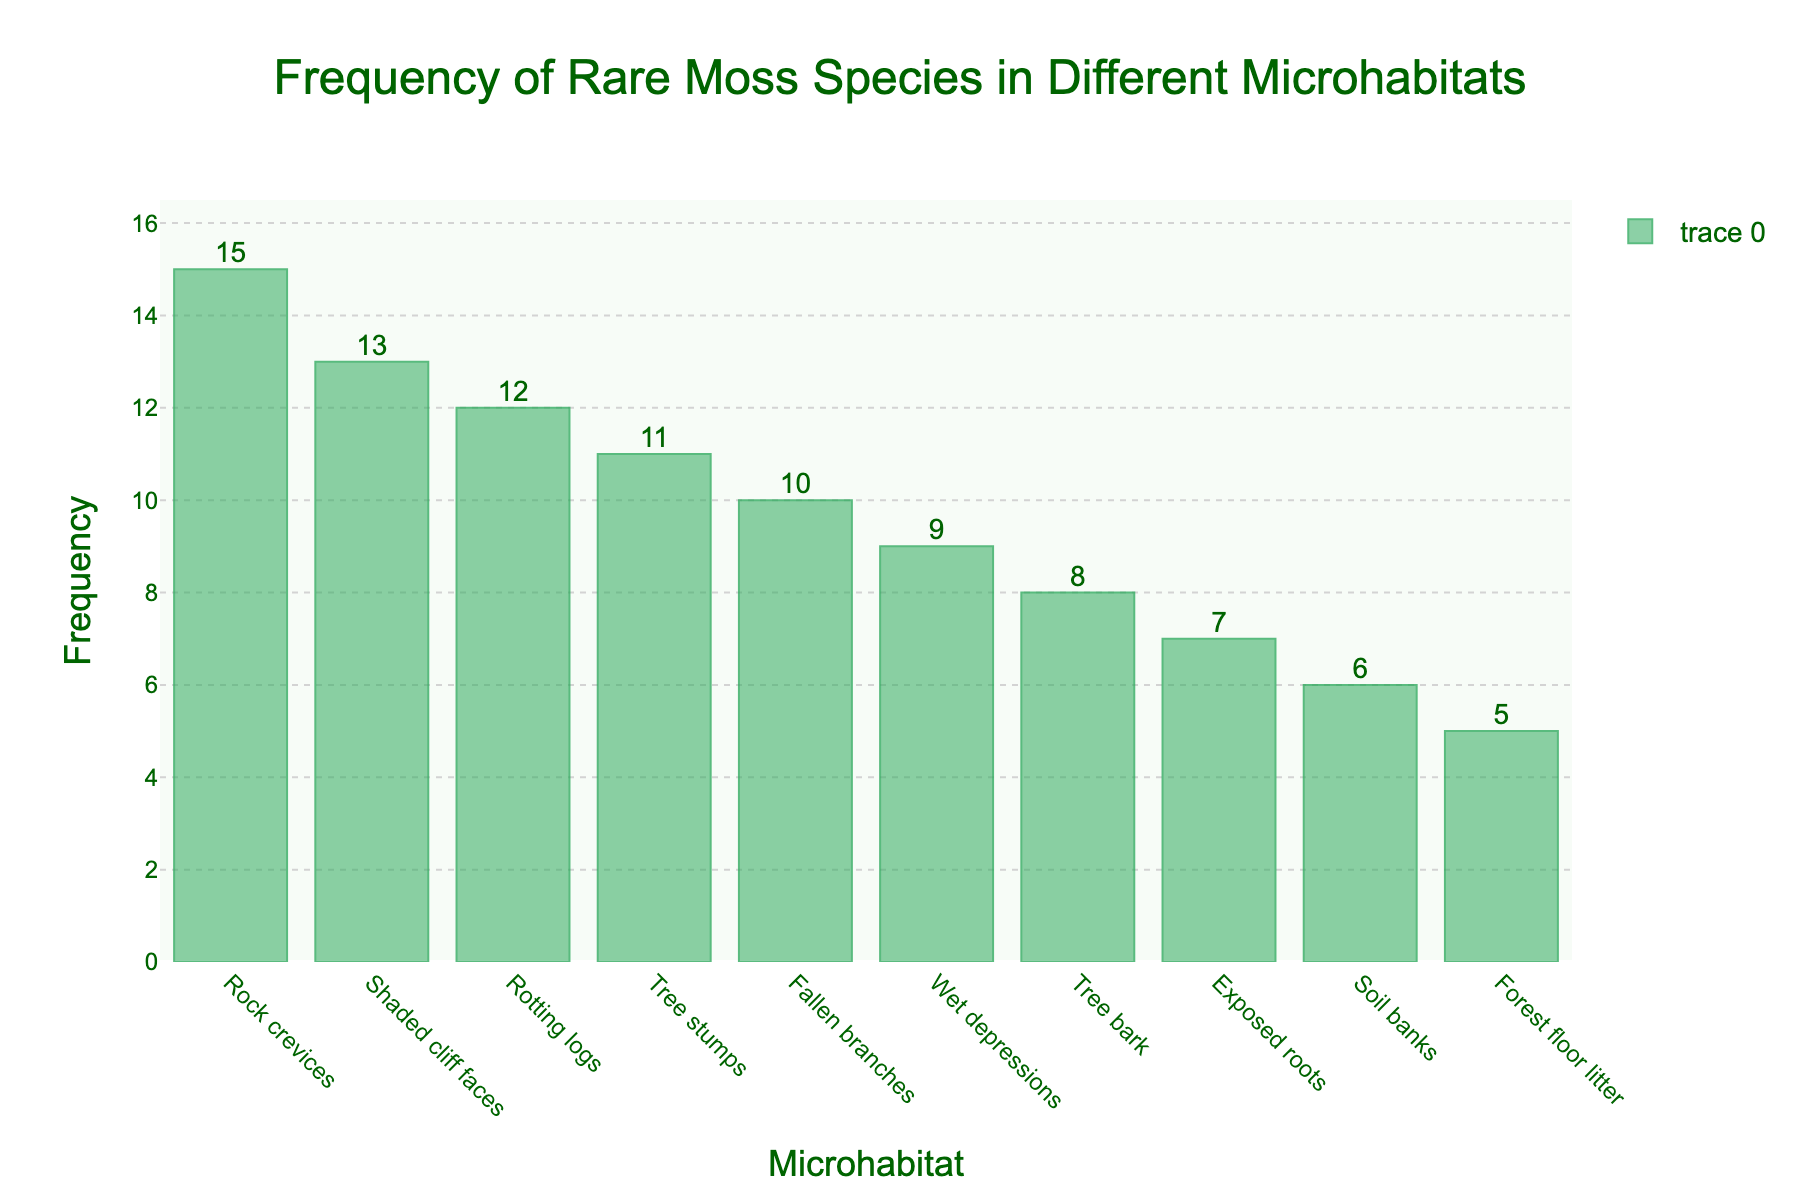Which microhabitat has the highest frequency of rare moss species? According to the histogram, "Rock crevices" has the tallest bar, which means it has the highest frequency.
Answer: Rock crevices What is the title of the histogram? The title of the histogram is displayed at the top and reads "Frequency of Rare Moss Species in Different Microhabitats".
Answer: Frequency of Rare Moss Species in Different Microhabitats How many microhabitats have a frequency greater than 10? Microhabitats with frequencies greater than 10 are "Rotting logs", "Rock crevices", "Shaded cliff faces", and "Tree stumps". This is 4 microhabitats.
Answer: 4 Which microhabitat has the lowest frequency? By observing the histogram, "Forest floor litter" has the shortest bar, indicating it has the lowest frequency.
Answer: Forest floor litter What is the combined frequency of rare moss species in "Tree bark" and "Fallen branches"? The frequency of "Tree bark" is 8 and "Fallen branches" is 10. Adding them together gives 8 + 10 = 18.
Answer: 18 Which microhabitat has a frequency closest to 10? Based on the histogram, "Fallen branches" has a frequency exactly equal to 10.
Answer: Fallen branches What is the frequency range shown on the y-axis? The y-axis starts at 0 and goes up to approximately 16, based on the highest bar and the extended range.
Answer: 0 to around 16 How does the frequency of "Tree stumps" compare to "Wet depressions"? "Tree stumps" has a frequency of 11 while "Wet depressions" has a frequency of 9. Therefore, "Tree stumps" has a higher frequency.
Answer: Tree stumps has a higher frequency What is the median frequency of the listed microhabitats? To find the median frequency, list the frequencies in ascending order: 5, 6, 7, 8, 9, 10, 11, 12, 13, 15. The median is the middle value in this ordered list. Since there are 10 values, the median is the average of the 5th and 6th values. (9 + 10) / 2 = 9.5.
Answer: 9.5 What does the bar color represent in the histogram? The bar color (various shades of green) is used to visually encode the frequency data, where the same green color is used consistently across all bars.
Answer: Frequency 